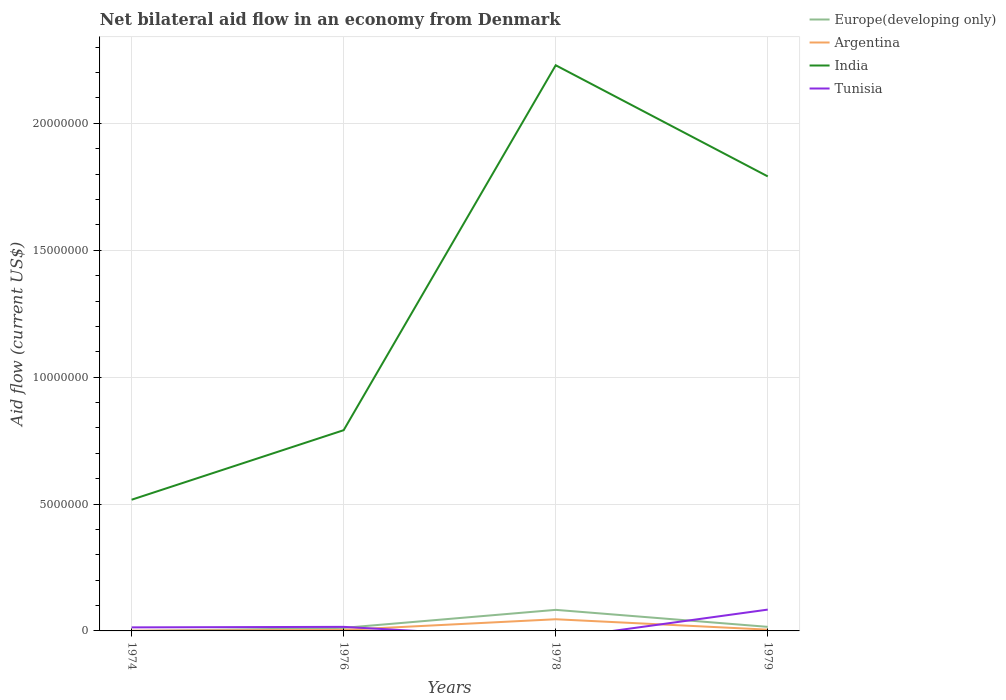What is the total net bilateral aid flow in Europe(developing only) in the graph?
Ensure brevity in your answer.  -4.00e+04. What is the difference between the highest and the second highest net bilateral aid flow in India?
Offer a terse response. 1.71e+07. Is the net bilateral aid flow in Europe(developing only) strictly greater than the net bilateral aid flow in Tunisia over the years?
Your response must be concise. No. What is the difference between two consecutive major ticks on the Y-axis?
Ensure brevity in your answer.  5.00e+06. Are the values on the major ticks of Y-axis written in scientific E-notation?
Make the answer very short. No. How many legend labels are there?
Your response must be concise. 4. How are the legend labels stacked?
Offer a very short reply. Vertical. What is the title of the graph?
Your answer should be very brief. Net bilateral aid flow in an economy from Denmark. Does "Montenegro" appear as one of the legend labels in the graph?
Provide a short and direct response. No. What is the label or title of the X-axis?
Ensure brevity in your answer.  Years. What is the Aid flow (current US$) of Europe(developing only) in 1974?
Make the answer very short. 0. What is the Aid flow (current US$) of Argentina in 1974?
Provide a succinct answer. 10000. What is the Aid flow (current US$) of India in 1974?
Offer a very short reply. 5.17e+06. What is the Aid flow (current US$) of India in 1976?
Offer a very short reply. 7.91e+06. What is the Aid flow (current US$) of Europe(developing only) in 1978?
Give a very brief answer. 8.30e+05. What is the Aid flow (current US$) in Argentina in 1978?
Offer a very short reply. 4.60e+05. What is the Aid flow (current US$) of India in 1978?
Offer a terse response. 2.23e+07. What is the Aid flow (current US$) in India in 1979?
Ensure brevity in your answer.  1.79e+07. What is the Aid flow (current US$) of Tunisia in 1979?
Your answer should be very brief. 8.40e+05. Across all years, what is the maximum Aid flow (current US$) in Europe(developing only)?
Make the answer very short. 8.30e+05. Across all years, what is the maximum Aid flow (current US$) in India?
Your answer should be compact. 2.23e+07. Across all years, what is the maximum Aid flow (current US$) of Tunisia?
Give a very brief answer. 8.40e+05. Across all years, what is the minimum Aid flow (current US$) of Argentina?
Keep it short and to the point. 10000. Across all years, what is the minimum Aid flow (current US$) of India?
Provide a short and direct response. 5.17e+06. What is the total Aid flow (current US$) of Europe(developing only) in the graph?
Your response must be concise. 1.11e+06. What is the total Aid flow (current US$) in Argentina in the graph?
Offer a very short reply. 5.60e+05. What is the total Aid flow (current US$) of India in the graph?
Keep it short and to the point. 5.33e+07. What is the total Aid flow (current US$) in Tunisia in the graph?
Make the answer very short. 1.14e+06. What is the difference between the Aid flow (current US$) in India in 1974 and that in 1976?
Offer a very short reply. -2.74e+06. What is the difference between the Aid flow (current US$) in Argentina in 1974 and that in 1978?
Provide a succinct answer. -4.50e+05. What is the difference between the Aid flow (current US$) of India in 1974 and that in 1978?
Make the answer very short. -1.71e+07. What is the difference between the Aid flow (current US$) of India in 1974 and that in 1979?
Offer a very short reply. -1.27e+07. What is the difference between the Aid flow (current US$) in Tunisia in 1974 and that in 1979?
Make the answer very short. -7.00e+05. What is the difference between the Aid flow (current US$) of Europe(developing only) in 1976 and that in 1978?
Your answer should be very brief. -7.10e+05. What is the difference between the Aid flow (current US$) of Argentina in 1976 and that in 1978?
Provide a succinct answer. -4.20e+05. What is the difference between the Aid flow (current US$) in India in 1976 and that in 1978?
Offer a very short reply. -1.44e+07. What is the difference between the Aid flow (current US$) of Argentina in 1976 and that in 1979?
Ensure brevity in your answer.  -10000. What is the difference between the Aid flow (current US$) in India in 1976 and that in 1979?
Offer a terse response. -1.00e+07. What is the difference between the Aid flow (current US$) in Tunisia in 1976 and that in 1979?
Give a very brief answer. -6.80e+05. What is the difference between the Aid flow (current US$) in Europe(developing only) in 1978 and that in 1979?
Provide a short and direct response. 6.70e+05. What is the difference between the Aid flow (current US$) in Argentina in 1978 and that in 1979?
Your answer should be compact. 4.10e+05. What is the difference between the Aid flow (current US$) in India in 1978 and that in 1979?
Provide a short and direct response. 4.38e+06. What is the difference between the Aid flow (current US$) in Argentina in 1974 and the Aid flow (current US$) in India in 1976?
Give a very brief answer. -7.90e+06. What is the difference between the Aid flow (current US$) in Argentina in 1974 and the Aid flow (current US$) in Tunisia in 1976?
Offer a terse response. -1.50e+05. What is the difference between the Aid flow (current US$) of India in 1974 and the Aid flow (current US$) of Tunisia in 1976?
Your answer should be compact. 5.01e+06. What is the difference between the Aid flow (current US$) of Argentina in 1974 and the Aid flow (current US$) of India in 1978?
Offer a terse response. -2.23e+07. What is the difference between the Aid flow (current US$) of Argentina in 1974 and the Aid flow (current US$) of India in 1979?
Provide a short and direct response. -1.79e+07. What is the difference between the Aid flow (current US$) in Argentina in 1974 and the Aid flow (current US$) in Tunisia in 1979?
Offer a very short reply. -8.30e+05. What is the difference between the Aid flow (current US$) in India in 1974 and the Aid flow (current US$) in Tunisia in 1979?
Your answer should be very brief. 4.33e+06. What is the difference between the Aid flow (current US$) of Europe(developing only) in 1976 and the Aid flow (current US$) of Argentina in 1978?
Give a very brief answer. -3.40e+05. What is the difference between the Aid flow (current US$) in Europe(developing only) in 1976 and the Aid flow (current US$) in India in 1978?
Provide a succinct answer. -2.22e+07. What is the difference between the Aid flow (current US$) of Argentina in 1976 and the Aid flow (current US$) of India in 1978?
Offer a terse response. -2.22e+07. What is the difference between the Aid flow (current US$) of Europe(developing only) in 1976 and the Aid flow (current US$) of India in 1979?
Keep it short and to the point. -1.78e+07. What is the difference between the Aid flow (current US$) in Europe(developing only) in 1976 and the Aid flow (current US$) in Tunisia in 1979?
Your response must be concise. -7.20e+05. What is the difference between the Aid flow (current US$) of Argentina in 1976 and the Aid flow (current US$) of India in 1979?
Give a very brief answer. -1.79e+07. What is the difference between the Aid flow (current US$) of Argentina in 1976 and the Aid flow (current US$) of Tunisia in 1979?
Ensure brevity in your answer.  -8.00e+05. What is the difference between the Aid flow (current US$) in India in 1976 and the Aid flow (current US$) in Tunisia in 1979?
Make the answer very short. 7.07e+06. What is the difference between the Aid flow (current US$) of Europe(developing only) in 1978 and the Aid flow (current US$) of Argentina in 1979?
Provide a succinct answer. 7.80e+05. What is the difference between the Aid flow (current US$) of Europe(developing only) in 1978 and the Aid flow (current US$) of India in 1979?
Give a very brief answer. -1.71e+07. What is the difference between the Aid flow (current US$) of Europe(developing only) in 1978 and the Aid flow (current US$) of Tunisia in 1979?
Your answer should be compact. -10000. What is the difference between the Aid flow (current US$) in Argentina in 1978 and the Aid flow (current US$) in India in 1979?
Ensure brevity in your answer.  -1.74e+07. What is the difference between the Aid flow (current US$) in Argentina in 1978 and the Aid flow (current US$) in Tunisia in 1979?
Your answer should be compact. -3.80e+05. What is the difference between the Aid flow (current US$) in India in 1978 and the Aid flow (current US$) in Tunisia in 1979?
Keep it short and to the point. 2.14e+07. What is the average Aid flow (current US$) of Europe(developing only) per year?
Your answer should be very brief. 2.78e+05. What is the average Aid flow (current US$) in India per year?
Provide a short and direct response. 1.33e+07. What is the average Aid flow (current US$) of Tunisia per year?
Keep it short and to the point. 2.85e+05. In the year 1974, what is the difference between the Aid flow (current US$) in Argentina and Aid flow (current US$) in India?
Ensure brevity in your answer.  -5.16e+06. In the year 1974, what is the difference between the Aid flow (current US$) in India and Aid flow (current US$) in Tunisia?
Make the answer very short. 5.03e+06. In the year 1976, what is the difference between the Aid flow (current US$) of Europe(developing only) and Aid flow (current US$) of India?
Make the answer very short. -7.79e+06. In the year 1976, what is the difference between the Aid flow (current US$) of Europe(developing only) and Aid flow (current US$) of Tunisia?
Provide a succinct answer. -4.00e+04. In the year 1976, what is the difference between the Aid flow (current US$) of Argentina and Aid flow (current US$) of India?
Provide a short and direct response. -7.87e+06. In the year 1976, what is the difference between the Aid flow (current US$) of Argentina and Aid flow (current US$) of Tunisia?
Give a very brief answer. -1.20e+05. In the year 1976, what is the difference between the Aid flow (current US$) in India and Aid flow (current US$) in Tunisia?
Your answer should be compact. 7.75e+06. In the year 1978, what is the difference between the Aid flow (current US$) in Europe(developing only) and Aid flow (current US$) in India?
Your answer should be very brief. -2.15e+07. In the year 1978, what is the difference between the Aid flow (current US$) in Argentina and Aid flow (current US$) in India?
Provide a succinct answer. -2.18e+07. In the year 1979, what is the difference between the Aid flow (current US$) of Europe(developing only) and Aid flow (current US$) of Argentina?
Your answer should be compact. 1.10e+05. In the year 1979, what is the difference between the Aid flow (current US$) in Europe(developing only) and Aid flow (current US$) in India?
Provide a short and direct response. -1.78e+07. In the year 1979, what is the difference between the Aid flow (current US$) of Europe(developing only) and Aid flow (current US$) of Tunisia?
Make the answer very short. -6.80e+05. In the year 1979, what is the difference between the Aid flow (current US$) of Argentina and Aid flow (current US$) of India?
Keep it short and to the point. -1.79e+07. In the year 1979, what is the difference between the Aid flow (current US$) in Argentina and Aid flow (current US$) in Tunisia?
Keep it short and to the point. -7.90e+05. In the year 1979, what is the difference between the Aid flow (current US$) of India and Aid flow (current US$) of Tunisia?
Keep it short and to the point. 1.71e+07. What is the ratio of the Aid flow (current US$) of India in 1974 to that in 1976?
Offer a very short reply. 0.65. What is the ratio of the Aid flow (current US$) in Tunisia in 1974 to that in 1976?
Provide a succinct answer. 0.88. What is the ratio of the Aid flow (current US$) in Argentina in 1974 to that in 1978?
Give a very brief answer. 0.02. What is the ratio of the Aid flow (current US$) of India in 1974 to that in 1978?
Make the answer very short. 0.23. What is the ratio of the Aid flow (current US$) of Argentina in 1974 to that in 1979?
Your response must be concise. 0.2. What is the ratio of the Aid flow (current US$) in India in 1974 to that in 1979?
Make the answer very short. 0.29. What is the ratio of the Aid flow (current US$) in Tunisia in 1974 to that in 1979?
Provide a succinct answer. 0.17. What is the ratio of the Aid flow (current US$) in Europe(developing only) in 1976 to that in 1978?
Your answer should be compact. 0.14. What is the ratio of the Aid flow (current US$) of Argentina in 1976 to that in 1978?
Offer a terse response. 0.09. What is the ratio of the Aid flow (current US$) of India in 1976 to that in 1978?
Keep it short and to the point. 0.35. What is the ratio of the Aid flow (current US$) of Argentina in 1976 to that in 1979?
Your answer should be very brief. 0.8. What is the ratio of the Aid flow (current US$) in India in 1976 to that in 1979?
Your answer should be compact. 0.44. What is the ratio of the Aid flow (current US$) in Tunisia in 1976 to that in 1979?
Offer a terse response. 0.19. What is the ratio of the Aid flow (current US$) of Europe(developing only) in 1978 to that in 1979?
Your response must be concise. 5.19. What is the ratio of the Aid flow (current US$) in India in 1978 to that in 1979?
Give a very brief answer. 1.24. What is the difference between the highest and the second highest Aid flow (current US$) in Europe(developing only)?
Make the answer very short. 6.70e+05. What is the difference between the highest and the second highest Aid flow (current US$) in India?
Ensure brevity in your answer.  4.38e+06. What is the difference between the highest and the second highest Aid flow (current US$) in Tunisia?
Make the answer very short. 6.80e+05. What is the difference between the highest and the lowest Aid flow (current US$) in Europe(developing only)?
Give a very brief answer. 8.30e+05. What is the difference between the highest and the lowest Aid flow (current US$) of Argentina?
Your answer should be very brief. 4.50e+05. What is the difference between the highest and the lowest Aid flow (current US$) of India?
Provide a succinct answer. 1.71e+07. What is the difference between the highest and the lowest Aid flow (current US$) in Tunisia?
Give a very brief answer. 8.40e+05. 